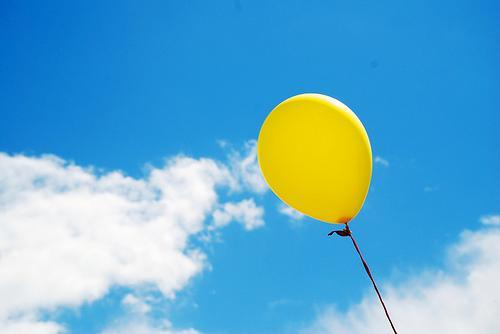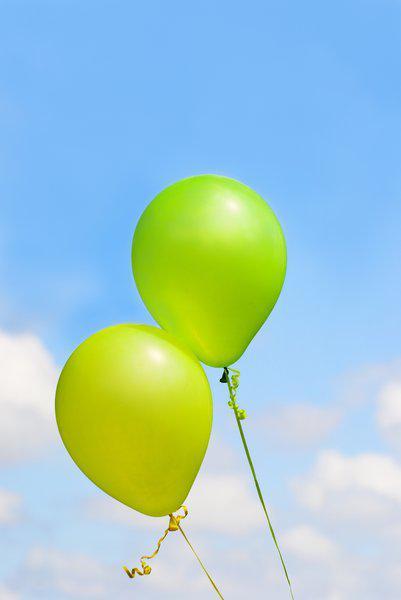The first image is the image on the left, the second image is the image on the right. Considering the images on both sides, is "An image contains exactly two yellowish balloons against a cloud-scattered blue sky." valid? Answer yes or no. Yes. The first image is the image on the left, the second image is the image on the right. For the images shown, is this caption "In at least one of the pictures, all of the balloons are yellow." true? Answer yes or no. Yes. 